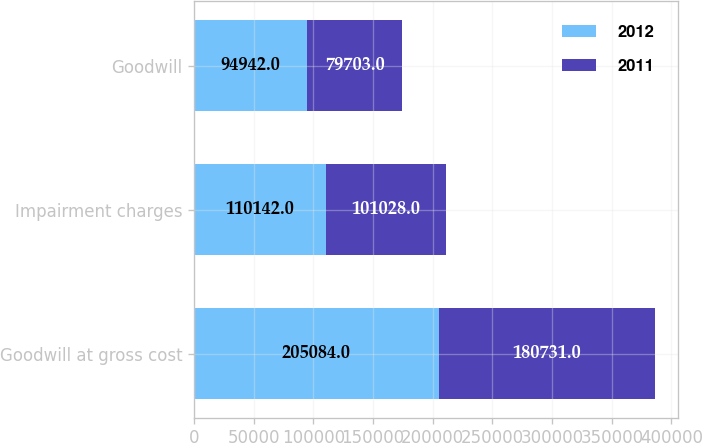Convert chart. <chart><loc_0><loc_0><loc_500><loc_500><stacked_bar_chart><ecel><fcel>Goodwill at gross cost<fcel>Impairment charges<fcel>Goodwill<nl><fcel>2012<fcel>205084<fcel>110142<fcel>94942<nl><fcel>2011<fcel>180731<fcel>101028<fcel>79703<nl></chart> 